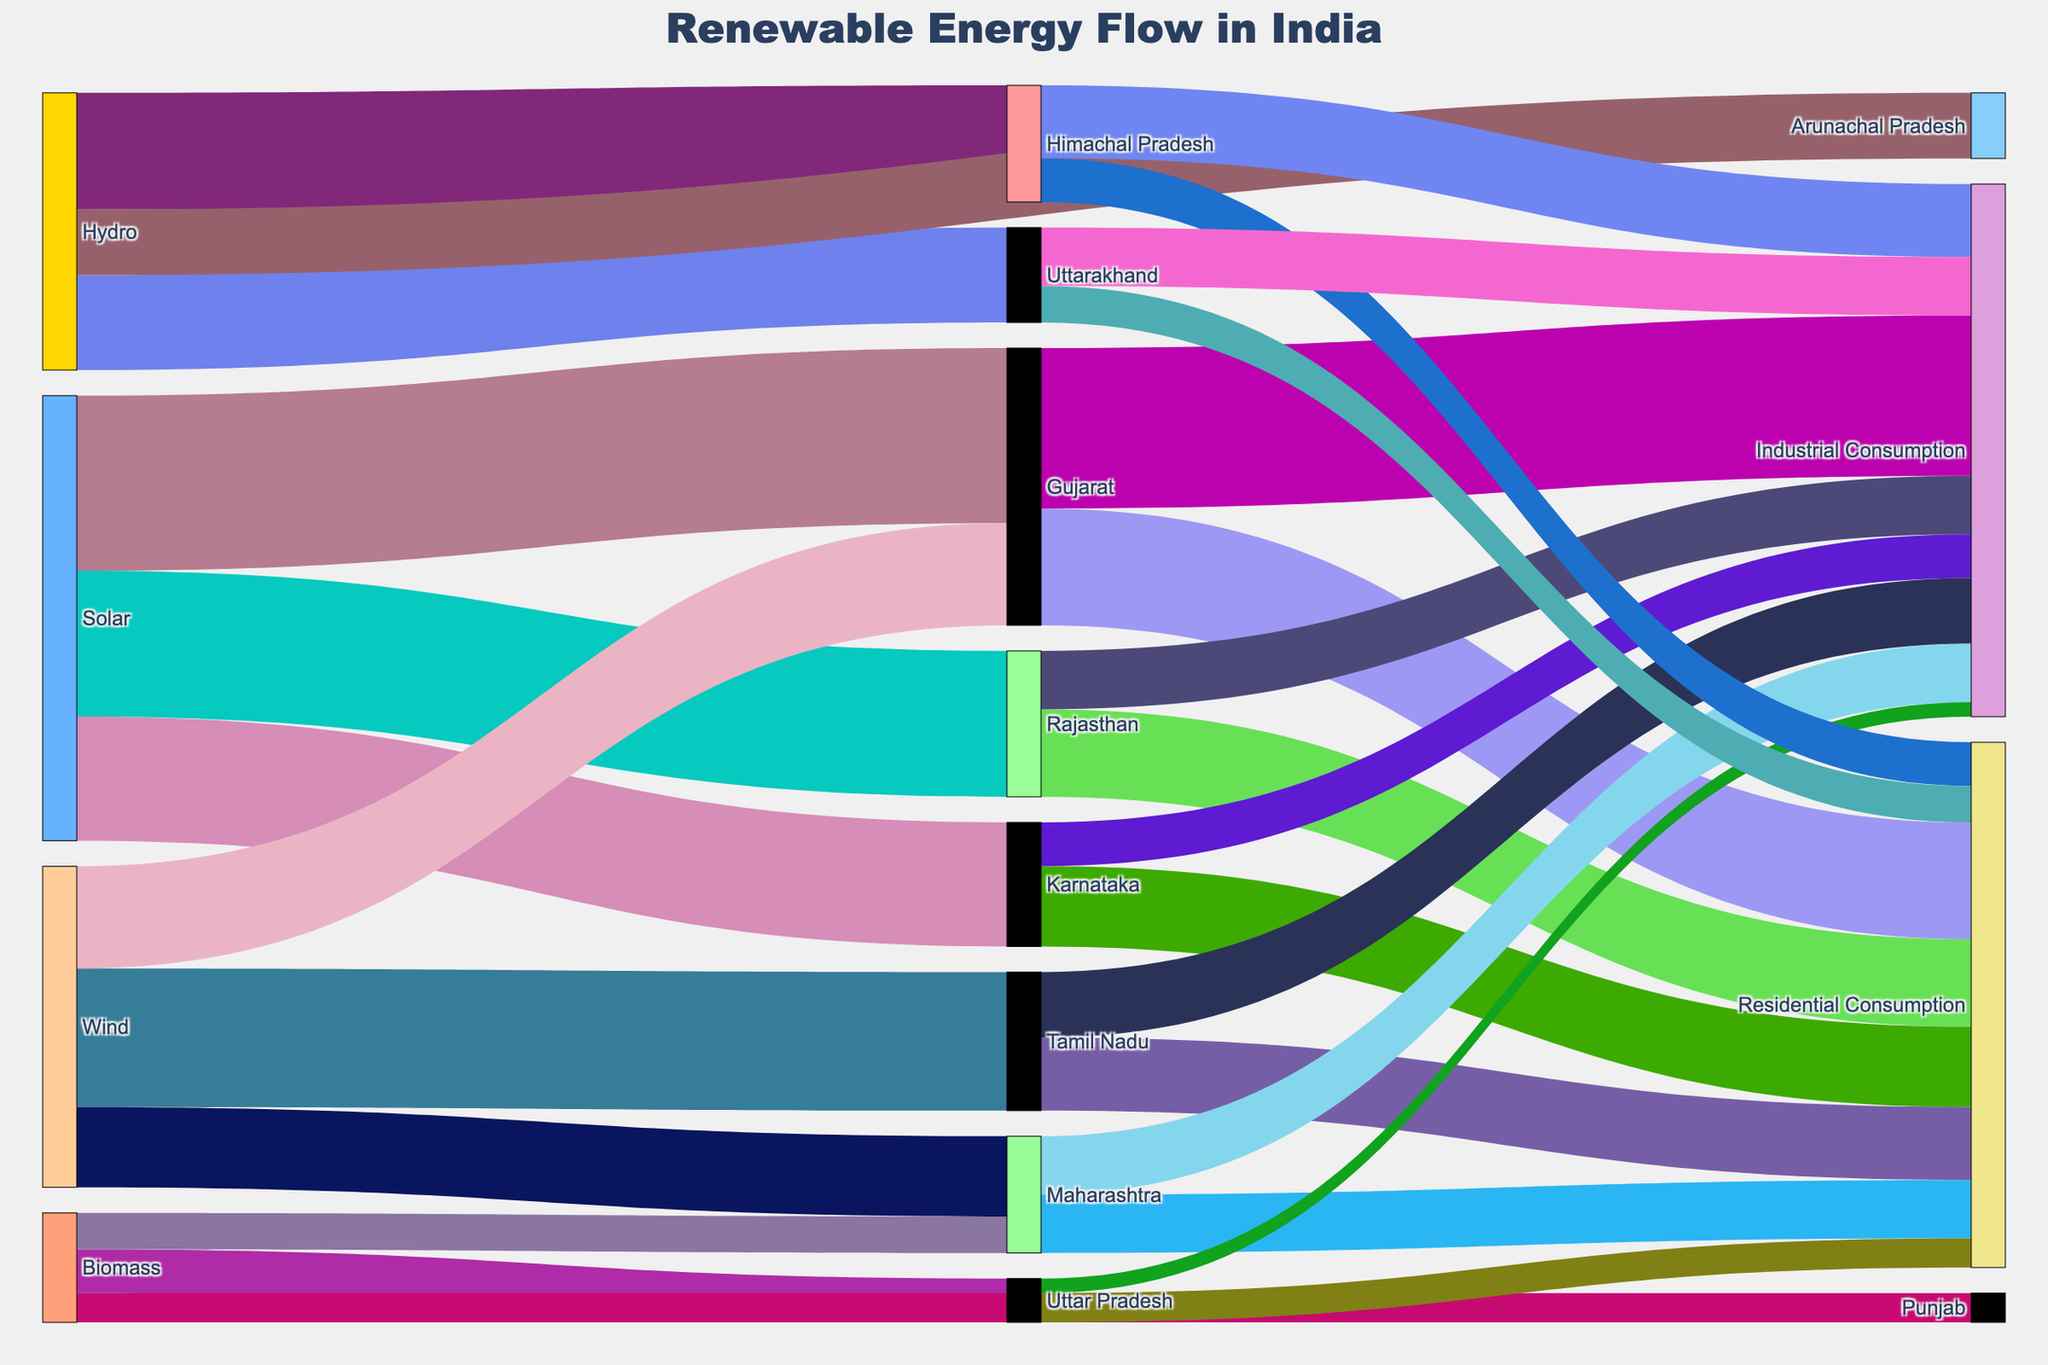What's the title of the Sankey diagram? The title of the Sankey diagram is located at the top of the figure. Reading it directly tells us the title.
Answer: Renewable Energy Flow in India Which state has the highest Solar energy production? In the diagram, follow the Solar energy source to identify each state it is connected to and look at the flow values. Gujarat has the highest flow value.
Answer: Gujarat How much total renewable energy is produced in Gujarat? Combine the values for all types of renewable energy flowing into Gujarat. There is 12000 from Solar and 7000 from Wind.
Answer: 19000 Which state has the lowest Biomass energy production? Follow the Biomass energy flow to the states and compare their values. Punjab has the lowest value at 2000.
Answer: Punjab What is the total Industrial Consumption in Himachal Pradesh? Identify the flow values from Himachal Pradesh to Industrial Consumption, the value is directly shown as 5000.
Answer: 5000 Compare the Residential Consumption between Tamil Nadu and Maharashtra. Which state has higher consumption and by how much? Follow the flow from each state to Residential Consumption. Tamil Nadu has 5000 and Maharashtra has 4000. Calculate the difference.
Answer: Tamil Nadu by 1000 Which energy source contributes the highest total value across all states? Sum the values connected to each energy source. Solar: 12000+10000+8500=30500, Wind: 9500+7000+5500=22000, Biomass: 3000+2500+2000=7500, Hydro: 8000+6500+4500=19000. Solar has the highest total.
Answer: Solar How much renewable energy is consumed industrially in Gujarat? Follow the flow from Gujarat to Industrial Consumption, which shows a value of 11000.
Answer: 11000 What is the combined Residential Consumption for Uttar Pradesh and Uttarakhand? Sum the values from Uttar Pradesh (2000) and Uttarakhand (2500) to Residential Consumption.
Answer: 4500 Which state has the highest total Renewable energy consumption (Residential + Industrial)? Add the Residential and Industrial Consumption for each state and compare. Tamil Nadu has the highest total: 5000 (Residential) + 4500 (Industrial) = 9500.
Answer: Tamil Nadu 